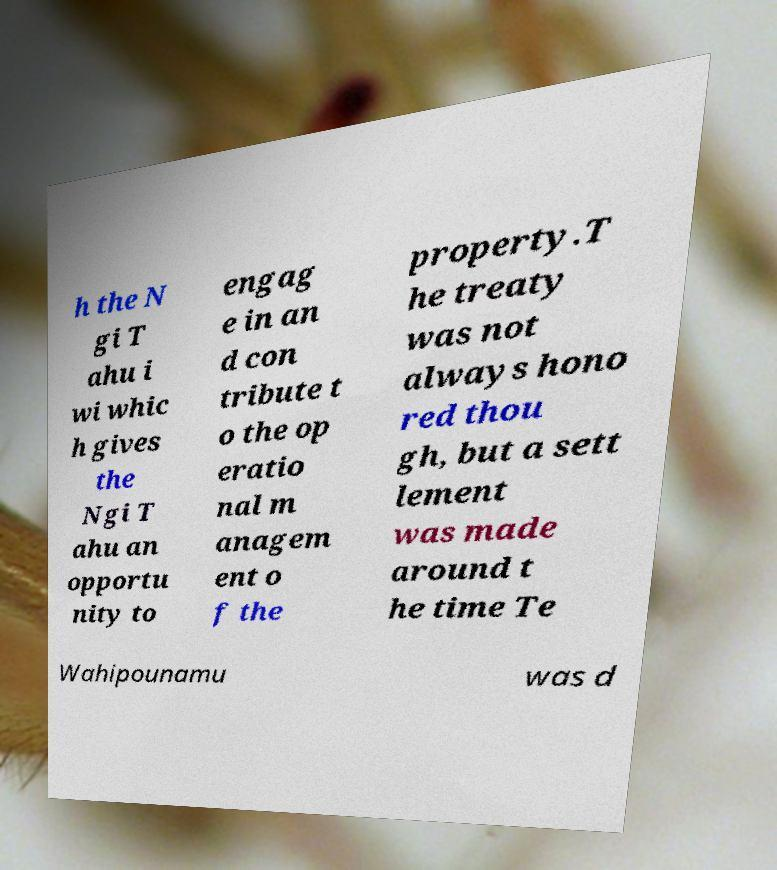Could you assist in decoding the text presented in this image and type it out clearly? h the N gi T ahu i wi whic h gives the Ngi T ahu an opportu nity to engag e in an d con tribute t o the op eratio nal m anagem ent o f the property.T he treaty was not always hono red thou gh, but a sett lement was made around t he time Te Wahipounamu was d 